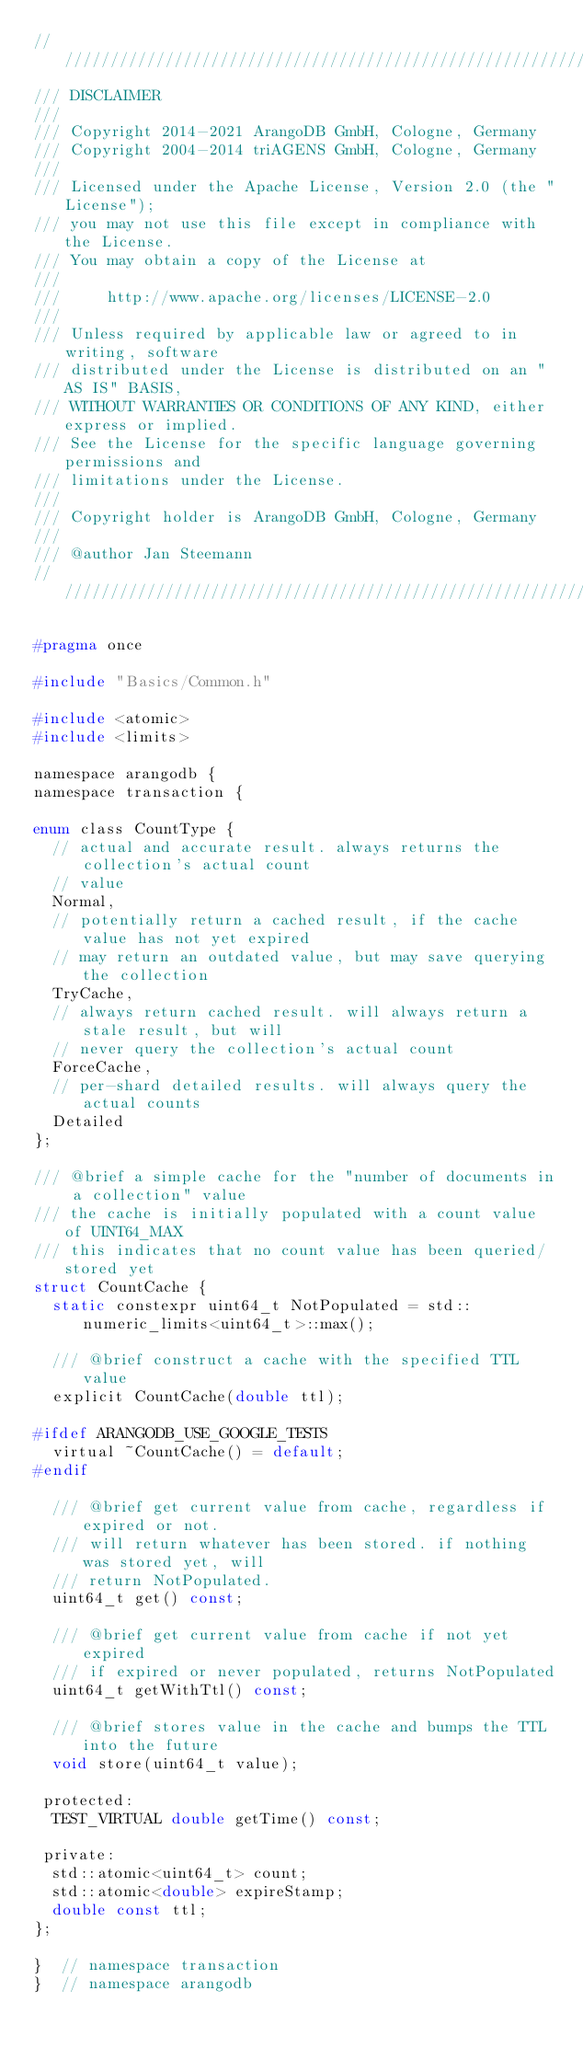Convert code to text. <code><loc_0><loc_0><loc_500><loc_500><_C_>////////////////////////////////////////////////////////////////////////////////
/// DISCLAIMER
///
/// Copyright 2014-2021 ArangoDB GmbH, Cologne, Germany
/// Copyright 2004-2014 triAGENS GmbH, Cologne, Germany
///
/// Licensed under the Apache License, Version 2.0 (the "License");
/// you may not use this file except in compliance with the License.
/// You may obtain a copy of the License at
///
///     http://www.apache.org/licenses/LICENSE-2.0
///
/// Unless required by applicable law or agreed to in writing, software
/// distributed under the License is distributed on an "AS IS" BASIS,
/// WITHOUT WARRANTIES OR CONDITIONS OF ANY KIND, either express or implied.
/// See the License for the specific language governing permissions and
/// limitations under the License.
///
/// Copyright holder is ArangoDB GmbH, Cologne, Germany
///
/// @author Jan Steemann
////////////////////////////////////////////////////////////////////////////////

#pragma once

#include "Basics/Common.h"

#include <atomic>
#include <limits>

namespace arangodb {
namespace transaction {

enum class CountType {
  // actual and accurate result. always returns the collection's actual count
  // value
  Normal,
  // potentially return a cached result, if the cache value has not yet expired
  // may return an outdated value, but may save querying the collection
  TryCache,
  // always return cached result. will always return a stale result, but will
  // never query the collection's actual count
  ForceCache,
  // per-shard detailed results. will always query the actual counts
  Detailed
};

/// @brief a simple cache for the "number of documents in a collection" value
/// the cache is initially populated with a count value of UINT64_MAX
/// this indicates that no count value has been queried/stored yet
struct CountCache {
  static constexpr uint64_t NotPopulated = std::numeric_limits<uint64_t>::max();

  /// @brief construct a cache with the specified TTL value
  explicit CountCache(double ttl);

#ifdef ARANGODB_USE_GOOGLE_TESTS
  virtual ~CountCache() = default;
#endif

  /// @brief get current value from cache, regardless if expired or not.
  /// will return whatever has been stored. if nothing was stored yet, will
  /// return NotPopulated.
  uint64_t get() const;

  /// @brief get current value from cache if not yet expired
  /// if expired or never populated, returns NotPopulated
  uint64_t getWithTtl() const;

  /// @brief stores value in the cache and bumps the TTL into the future
  void store(uint64_t value);

 protected:
  TEST_VIRTUAL double getTime() const;

 private:
  std::atomic<uint64_t> count;
  std::atomic<double> expireStamp;
  double const ttl;
};

}  // namespace transaction
}  // namespace arangodb

</code> 